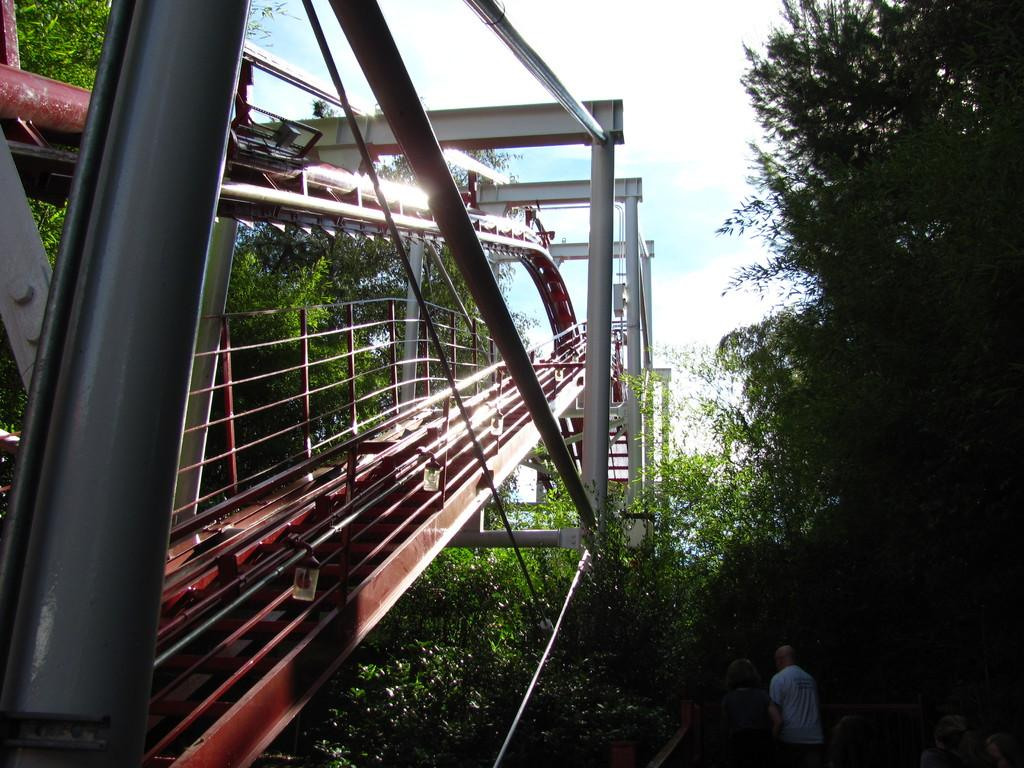What objects can be seen in the image? There are rods and trees in the image. Are there any living beings in the image? Yes, there are people at the bottom of the image. What is visible at the top of the image? The sky is visible at the top of the image. What can be observed in the sky? Clouds are present in the sky. What type of apple does the daughter bring to her partner in the image? There is no daughter, apple, or partner present in the image. 